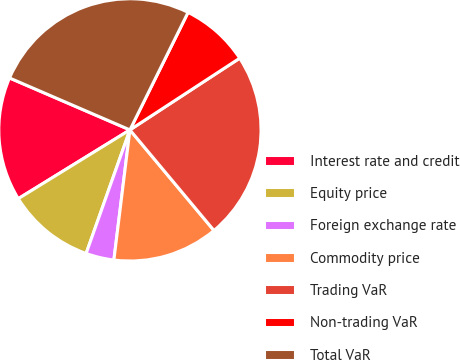Convert chart to OTSL. <chart><loc_0><loc_0><loc_500><loc_500><pie_chart><fcel>Interest rate and credit<fcel>Equity price<fcel>Foreign exchange rate<fcel>Commodity price<fcel>Trading VaR<fcel>Non-trading VaR<fcel>Total VaR<nl><fcel>15.27%<fcel>10.79%<fcel>3.47%<fcel>13.03%<fcel>23.13%<fcel>8.48%<fcel>25.83%<nl></chart> 